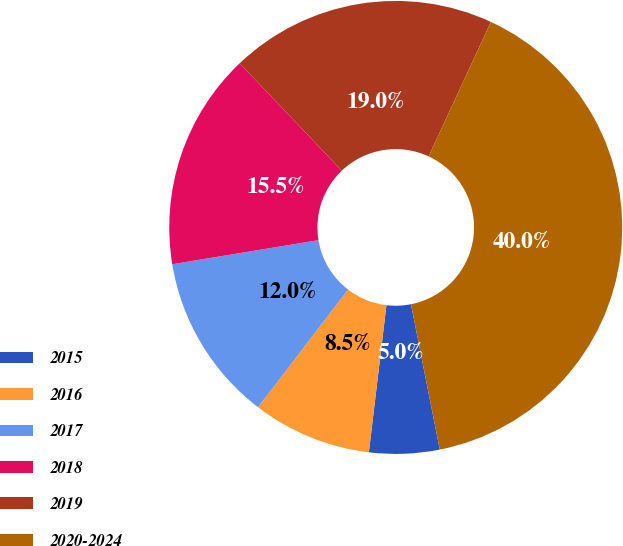Convert chart to OTSL. <chart><loc_0><loc_0><loc_500><loc_500><pie_chart><fcel>2015<fcel>2016<fcel>2017<fcel>2018<fcel>2019<fcel>2020-2024<nl><fcel>5.01%<fcel>8.51%<fcel>12.0%<fcel>15.5%<fcel>19.0%<fcel>39.98%<nl></chart> 